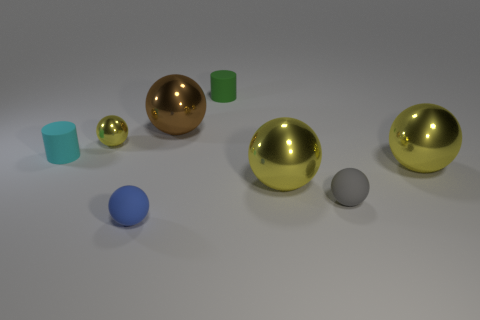What number of large balls are there?
Keep it short and to the point. 3. What number of other brown spheres are the same size as the brown metallic sphere?
Provide a short and direct response. 0. What is the small cyan cylinder made of?
Provide a short and direct response. Rubber. Does the tiny shiny ball have the same color as the big object right of the gray matte ball?
Keep it short and to the point. Yes. There is a yellow thing that is left of the gray matte sphere and to the right of the small yellow shiny ball; how big is it?
Make the answer very short. Large. There is a tiny blue thing that is the same material as the green object; what shape is it?
Provide a short and direct response. Sphere. Is the tiny blue object made of the same material as the small cylinder to the left of the blue sphere?
Provide a short and direct response. Yes. There is a small sphere that is on the right side of the blue thing; is there a small rubber cylinder that is on the left side of it?
Keep it short and to the point. Yes. What material is the big brown object that is the same shape as the tiny yellow object?
Provide a succinct answer. Metal. What number of small cyan matte things are right of the large ball left of the green object?
Give a very brief answer. 0. 